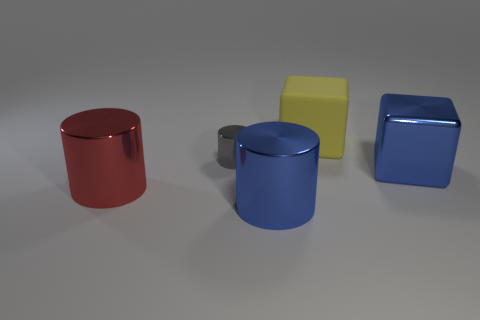Add 2 tiny yellow rubber cylinders. How many objects exist? 7 Subtract all cylinders. How many objects are left? 2 Add 5 big yellow objects. How many big yellow objects exist? 6 Subtract 1 red cylinders. How many objects are left? 4 Subtract all tiny gray matte cylinders. Subtract all tiny gray cylinders. How many objects are left? 4 Add 4 large metal objects. How many large metal objects are left? 7 